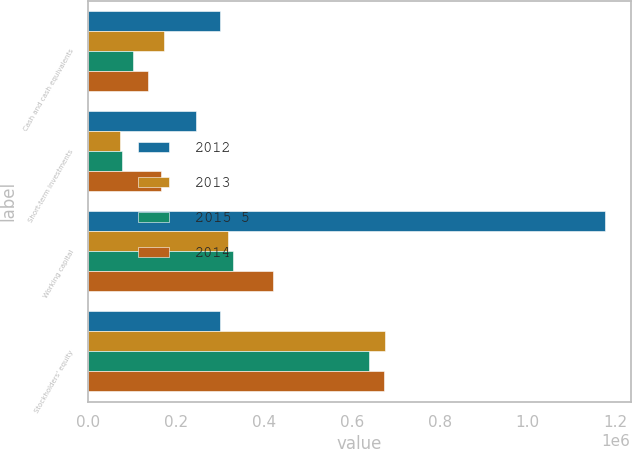<chart> <loc_0><loc_0><loc_500><loc_500><stacked_bar_chart><ecel><fcel>Cash and cash equivalents<fcel>Short-term investments<fcel>Working capital<fcel>Stockholders' equity<nl><fcel>2012<fcel>299814<fcel>244830<fcel>1.1748e+06<fcel>299814<nl><fcel>2013<fcel>171898<fcel>72067<fcel>317445<fcel>676351<nl><fcel>2015 5<fcel>101662<fcel>77987<fcel>330523<fcel>639014<nl><fcel>2014<fcel>135524<fcel>164863<fcel>421182<fcel>672331<nl></chart> 